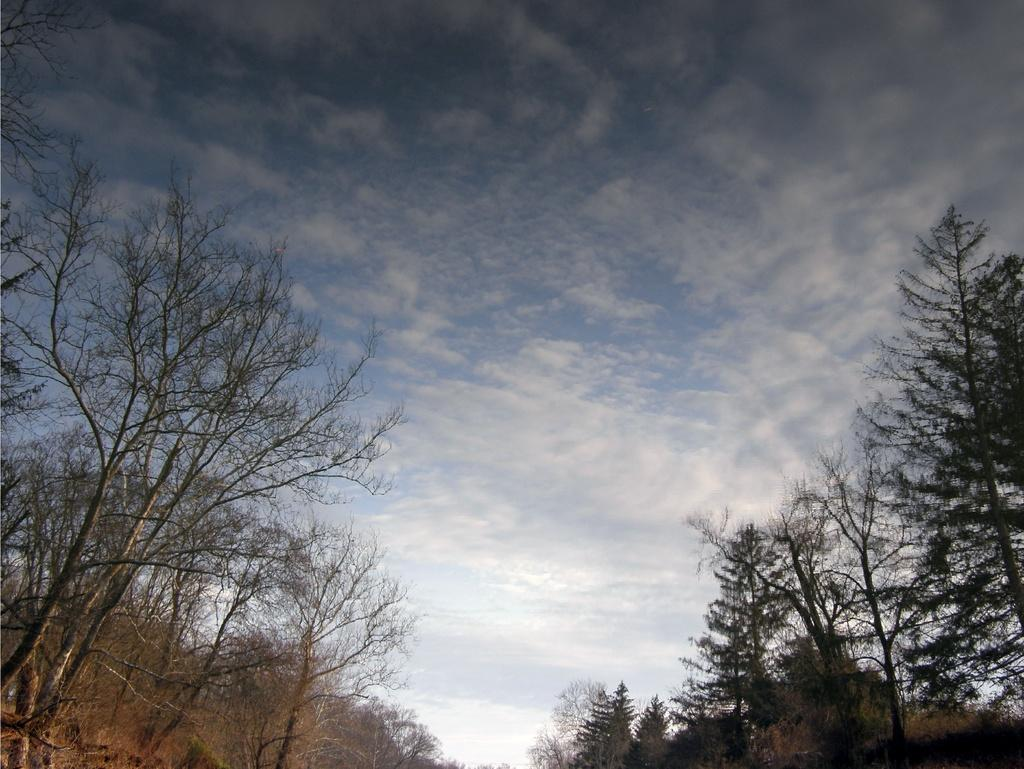What type of vegetation can be seen in the image? There is a group of trees in the image. What is visible at the top of the image? The sky is visible at the top of the image. How would you describe the sky in the image? The sky appears to be cloudy. How many breaths can be counted coming from the trees in the image? Trees do not breathe like animals, so it is not possible to count breaths coming from the trees in the image. 